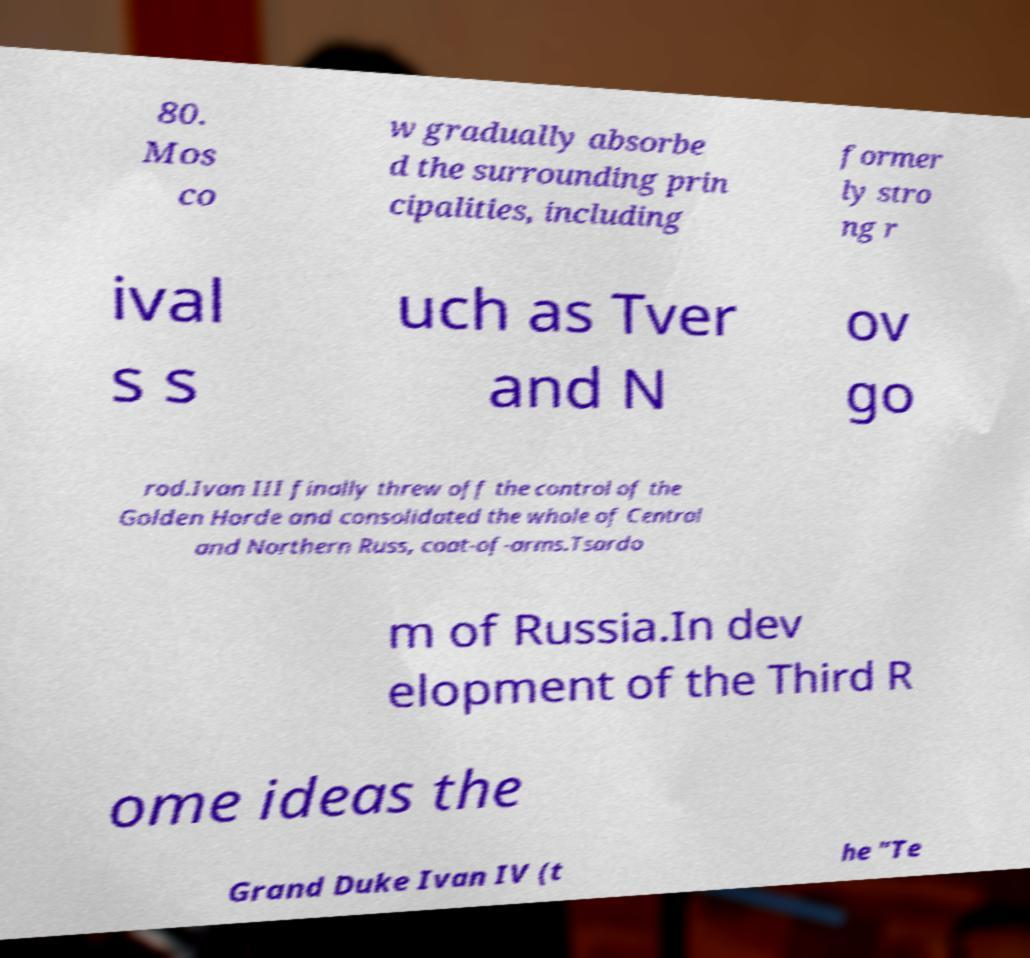Could you assist in decoding the text presented in this image and type it out clearly? 80. Mos co w gradually absorbe d the surrounding prin cipalities, including former ly stro ng r ival s s uch as Tver and N ov go rod.Ivan III finally threw off the control of the Golden Horde and consolidated the whole of Central and Northern Russ, coat-of-arms.Tsardo m of Russia.In dev elopment of the Third R ome ideas the Grand Duke Ivan IV (t he "Te 